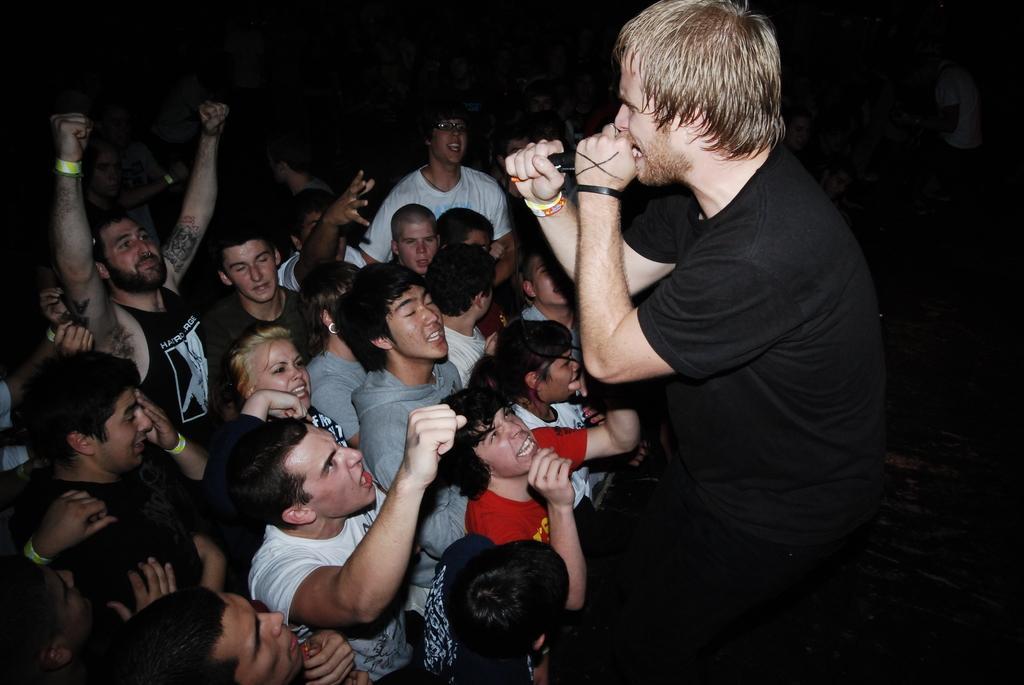Describe this image in one or two sentences. This image is taken indoors. In this image the background is dark. On the right side of the image a man is standing and singing and he is holding a mic in his hands. In the middle of the image many people are standing. 